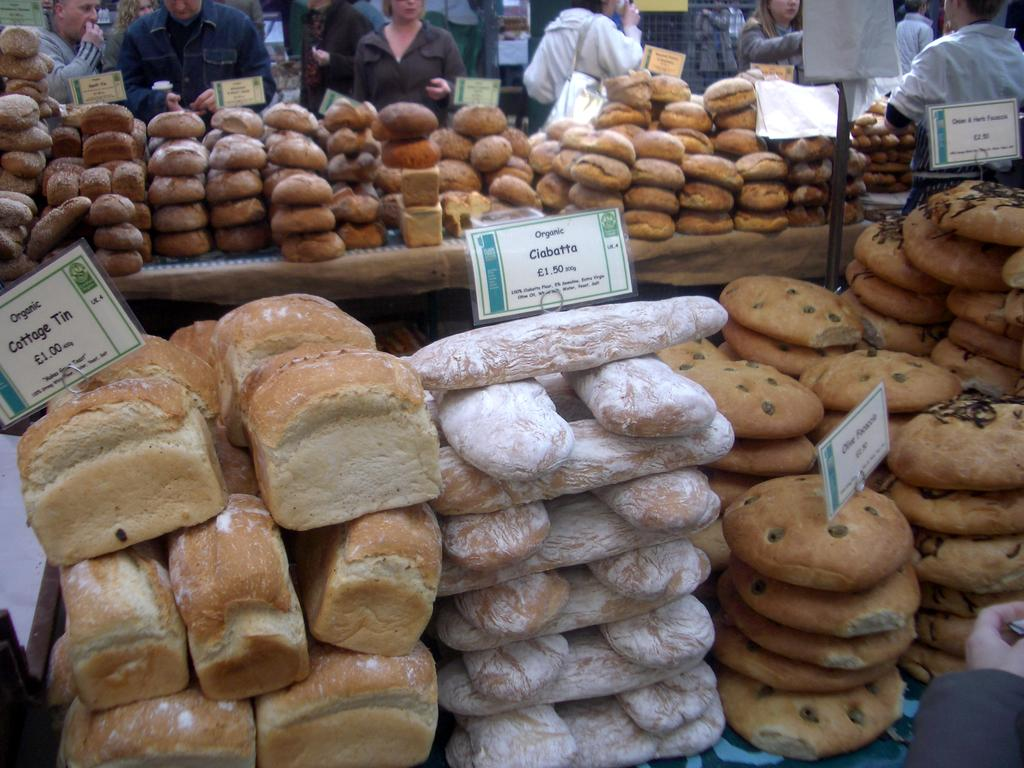What colors are the food items in the image? The food items in the image are in brown and white colors. What else can be seen in the image besides the food items? There are boards and people visible in the image. Can you describe the people in the image? The people in the image are wearing different color dresses. What type of haircut can be seen on the twig in the image? There is no twig present in the image, and therefore no haircut can be observed. 